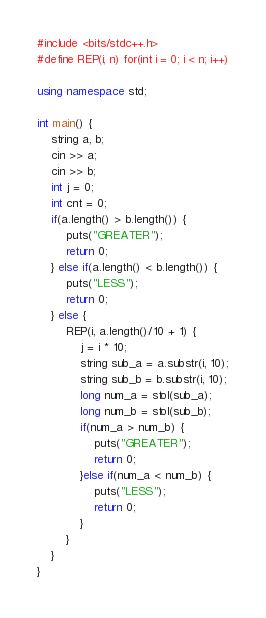<code> <loc_0><loc_0><loc_500><loc_500><_C++_>#include <bits/stdc++.h>
#define REP(i, n) for(int i = 0; i < n; i++)

using namespace std;

int main() {
    string a, b;
    cin >> a;
    cin >> b;
    int j = 0;
    int cnt = 0;
    if(a.length() > b.length()) {
        puts("GREATER");
        return 0;
    } else if(a.length() < b.length()) {
        puts("LESS");
        return 0;
    } else {
        REP(i, a.length()/10 + 1) {
            j = i * 10;
            string sub_a = a.substr(i, 10);
            string sub_b = b.substr(i, 10);
            long num_a = stol(sub_a);
            long num_b = stol(sub_b);
            if(num_a > num_b) {
                puts("GREATER");
                return 0;
            }else if(num_a < num_b) {
                puts("LESS");
                return 0;
            }
        }
    }
}</code> 